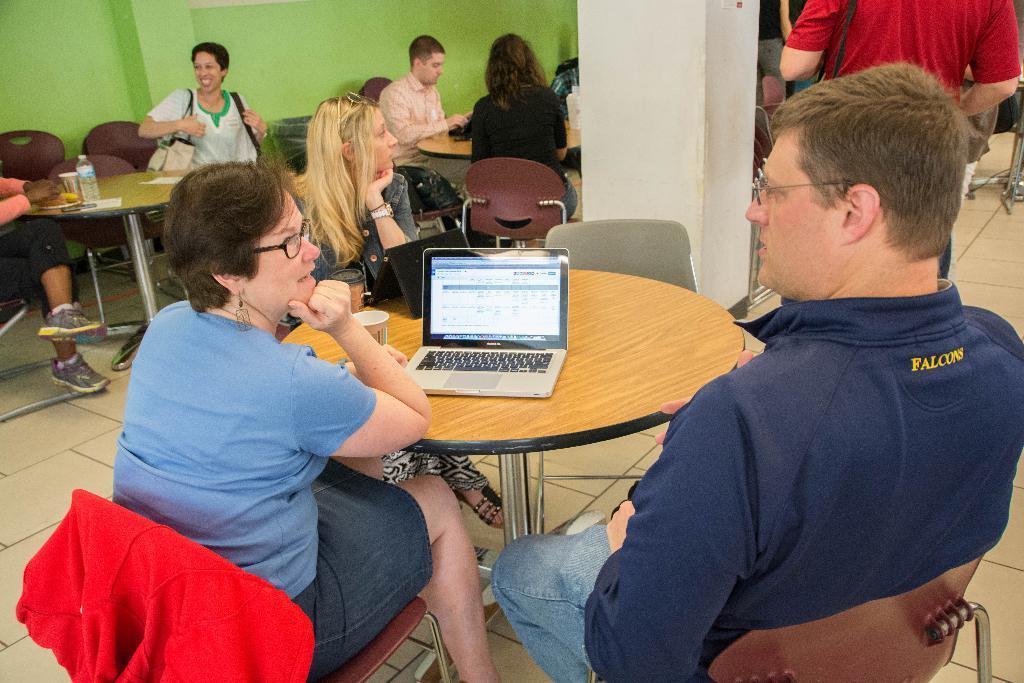How would you summarize this image in a sentence or two? In this image we can see people sitting on the chairs and tables are placed in front of them. On the tables we can see disposable bottles, serving plates with food, disposal tumblers, a laptop, tablets and bags. 